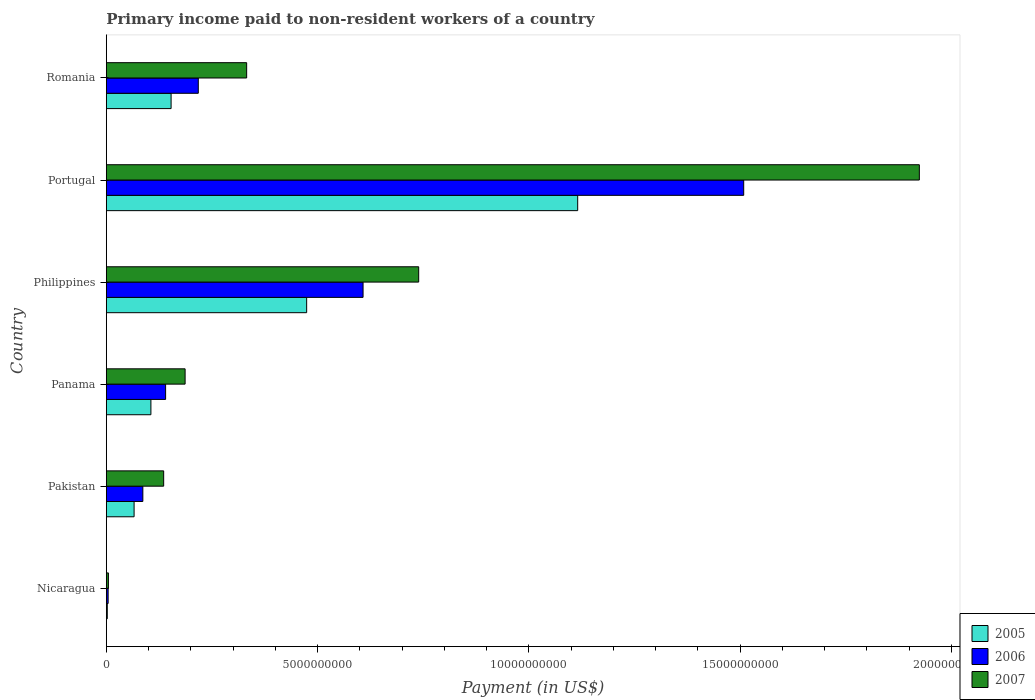Are the number of bars per tick equal to the number of legend labels?
Your response must be concise. Yes. Are the number of bars on each tick of the Y-axis equal?
Your answer should be compact. Yes. How many bars are there on the 1st tick from the top?
Make the answer very short. 3. What is the label of the 6th group of bars from the top?
Your answer should be very brief. Nicaragua. What is the amount paid to workers in 2006 in Pakistan?
Offer a terse response. 8.64e+08. Across all countries, what is the maximum amount paid to workers in 2006?
Your answer should be very brief. 1.51e+1. Across all countries, what is the minimum amount paid to workers in 2006?
Offer a terse response. 4.26e+07. In which country was the amount paid to workers in 2007 maximum?
Offer a terse response. Portugal. In which country was the amount paid to workers in 2006 minimum?
Provide a succinct answer. Nicaragua. What is the total amount paid to workers in 2007 in the graph?
Offer a very short reply. 3.32e+1. What is the difference between the amount paid to workers in 2007 in Philippines and that in Romania?
Provide a short and direct response. 4.07e+09. What is the difference between the amount paid to workers in 2007 in Nicaragua and the amount paid to workers in 2006 in Portugal?
Your answer should be compact. -1.50e+1. What is the average amount paid to workers in 2005 per country?
Ensure brevity in your answer.  3.19e+09. What is the ratio of the amount paid to workers in 2007 in Philippines to that in Romania?
Keep it short and to the point. 2.23. Is the amount paid to workers in 2005 in Pakistan less than that in Romania?
Your answer should be very brief. Yes. What is the difference between the highest and the second highest amount paid to workers in 2006?
Keep it short and to the point. 9.01e+09. What is the difference between the highest and the lowest amount paid to workers in 2005?
Offer a very short reply. 1.11e+1. In how many countries, is the amount paid to workers in 2005 greater than the average amount paid to workers in 2005 taken over all countries?
Provide a succinct answer. 2. Is the sum of the amount paid to workers in 2006 in Portugal and Romania greater than the maximum amount paid to workers in 2005 across all countries?
Provide a short and direct response. Yes. What does the 1st bar from the bottom in Portugal represents?
Make the answer very short. 2005. Is it the case that in every country, the sum of the amount paid to workers in 2006 and amount paid to workers in 2007 is greater than the amount paid to workers in 2005?
Offer a terse response. Yes. How many bars are there?
Offer a very short reply. 18. Are all the bars in the graph horizontal?
Offer a terse response. Yes. How many countries are there in the graph?
Offer a very short reply. 6. What is the difference between two consecutive major ticks on the X-axis?
Your answer should be very brief. 5.00e+09. Are the values on the major ticks of X-axis written in scientific E-notation?
Ensure brevity in your answer.  No. Does the graph contain any zero values?
Offer a very short reply. No. What is the title of the graph?
Ensure brevity in your answer.  Primary income paid to non-resident workers of a country. Does "1986" appear as one of the legend labels in the graph?
Keep it short and to the point. No. What is the label or title of the X-axis?
Your answer should be very brief. Payment (in US$). What is the label or title of the Y-axis?
Your answer should be compact. Country. What is the Payment (in US$) of 2005 in Nicaragua?
Offer a terse response. 2.27e+07. What is the Payment (in US$) in 2006 in Nicaragua?
Provide a succinct answer. 4.26e+07. What is the Payment (in US$) of 2007 in Nicaragua?
Your answer should be very brief. 4.96e+07. What is the Payment (in US$) in 2005 in Pakistan?
Provide a short and direct response. 6.57e+08. What is the Payment (in US$) in 2006 in Pakistan?
Keep it short and to the point. 8.64e+08. What is the Payment (in US$) of 2007 in Pakistan?
Ensure brevity in your answer.  1.36e+09. What is the Payment (in US$) in 2005 in Panama?
Offer a terse response. 1.05e+09. What is the Payment (in US$) in 2006 in Panama?
Provide a short and direct response. 1.40e+09. What is the Payment (in US$) of 2007 in Panama?
Your response must be concise. 1.86e+09. What is the Payment (in US$) of 2005 in Philippines?
Provide a short and direct response. 4.74e+09. What is the Payment (in US$) of 2006 in Philippines?
Provide a succinct answer. 6.08e+09. What is the Payment (in US$) in 2007 in Philippines?
Provide a succinct answer. 7.39e+09. What is the Payment (in US$) of 2005 in Portugal?
Provide a succinct answer. 1.12e+1. What is the Payment (in US$) of 2006 in Portugal?
Your answer should be very brief. 1.51e+1. What is the Payment (in US$) of 2007 in Portugal?
Your answer should be very brief. 1.92e+1. What is the Payment (in US$) in 2005 in Romania?
Offer a very short reply. 1.53e+09. What is the Payment (in US$) in 2006 in Romania?
Your answer should be very brief. 2.18e+09. What is the Payment (in US$) of 2007 in Romania?
Provide a short and direct response. 3.32e+09. Across all countries, what is the maximum Payment (in US$) in 2005?
Provide a short and direct response. 1.12e+1. Across all countries, what is the maximum Payment (in US$) of 2006?
Ensure brevity in your answer.  1.51e+1. Across all countries, what is the maximum Payment (in US$) in 2007?
Your answer should be very brief. 1.92e+1. Across all countries, what is the minimum Payment (in US$) of 2005?
Make the answer very short. 2.27e+07. Across all countries, what is the minimum Payment (in US$) in 2006?
Provide a succinct answer. 4.26e+07. Across all countries, what is the minimum Payment (in US$) in 2007?
Give a very brief answer. 4.96e+07. What is the total Payment (in US$) in 2005 in the graph?
Give a very brief answer. 1.92e+1. What is the total Payment (in US$) in 2006 in the graph?
Ensure brevity in your answer.  2.56e+1. What is the total Payment (in US$) in 2007 in the graph?
Offer a very short reply. 3.32e+1. What is the difference between the Payment (in US$) in 2005 in Nicaragua and that in Pakistan?
Give a very brief answer. -6.34e+08. What is the difference between the Payment (in US$) in 2006 in Nicaragua and that in Pakistan?
Ensure brevity in your answer.  -8.21e+08. What is the difference between the Payment (in US$) in 2007 in Nicaragua and that in Pakistan?
Your answer should be compact. -1.31e+09. What is the difference between the Payment (in US$) in 2005 in Nicaragua and that in Panama?
Provide a short and direct response. -1.03e+09. What is the difference between the Payment (in US$) of 2006 in Nicaragua and that in Panama?
Provide a short and direct response. -1.36e+09. What is the difference between the Payment (in US$) in 2007 in Nicaragua and that in Panama?
Give a very brief answer. -1.81e+09. What is the difference between the Payment (in US$) of 2005 in Nicaragua and that in Philippines?
Your response must be concise. -4.72e+09. What is the difference between the Payment (in US$) of 2006 in Nicaragua and that in Philippines?
Provide a succinct answer. -6.03e+09. What is the difference between the Payment (in US$) in 2007 in Nicaragua and that in Philippines?
Offer a terse response. -7.34e+09. What is the difference between the Payment (in US$) in 2005 in Nicaragua and that in Portugal?
Keep it short and to the point. -1.11e+1. What is the difference between the Payment (in US$) in 2006 in Nicaragua and that in Portugal?
Your answer should be compact. -1.50e+1. What is the difference between the Payment (in US$) of 2007 in Nicaragua and that in Portugal?
Your response must be concise. -1.92e+1. What is the difference between the Payment (in US$) of 2005 in Nicaragua and that in Romania?
Provide a succinct answer. -1.51e+09. What is the difference between the Payment (in US$) of 2006 in Nicaragua and that in Romania?
Provide a short and direct response. -2.13e+09. What is the difference between the Payment (in US$) of 2007 in Nicaragua and that in Romania?
Offer a terse response. -3.27e+09. What is the difference between the Payment (in US$) of 2005 in Pakistan and that in Panama?
Provide a short and direct response. -3.98e+08. What is the difference between the Payment (in US$) in 2006 in Pakistan and that in Panama?
Your response must be concise. -5.39e+08. What is the difference between the Payment (in US$) in 2007 in Pakistan and that in Panama?
Ensure brevity in your answer.  -5.07e+08. What is the difference between the Payment (in US$) of 2005 in Pakistan and that in Philippines?
Keep it short and to the point. -4.08e+09. What is the difference between the Payment (in US$) of 2006 in Pakistan and that in Philippines?
Provide a succinct answer. -5.21e+09. What is the difference between the Payment (in US$) of 2007 in Pakistan and that in Philippines?
Keep it short and to the point. -6.04e+09. What is the difference between the Payment (in US$) in 2005 in Pakistan and that in Portugal?
Provide a succinct answer. -1.05e+1. What is the difference between the Payment (in US$) in 2006 in Pakistan and that in Portugal?
Offer a very short reply. -1.42e+1. What is the difference between the Payment (in US$) in 2007 in Pakistan and that in Portugal?
Offer a very short reply. -1.79e+1. What is the difference between the Payment (in US$) in 2005 in Pakistan and that in Romania?
Your response must be concise. -8.76e+08. What is the difference between the Payment (in US$) of 2006 in Pakistan and that in Romania?
Provide a short and direct response. -1.31e+09. What is the difference between the Payment (in US$) of 2007 in Pakistan and that in Romania?
Give a very brief answer. -1.96e+09. What is the difference between the Payment (in US$) in 2005 in Panama and that in Philippines?
Your response must be concise. -3.69e+09. What is the difference between the Payment (in US$) in 2006 in Panama and that in Philippines?
Your response must be concise. -4.67e+09. What is the difference between the Payment (in US$) of 2007 in Panama and that in Philippines?
Provide a succinct answer. -5.53e+09. What is the difference between the Payment (in US$) of 2005 in Panama and that in Portugal?
Provide a succinct answer. -1.01e+1. What is the difference between the Payment (in US$) of 2006 in Panama and that in Portugal?
Provide a succinct answer. -1.37e+1. What is the difference between the Payment (in US$) in 2007 in Panama and that in Portugal?
Your response must be concise. -1.74e+1. What is the difference between the Payment (in US$) in 2005 in Panama and that in Romania?
Give a very brief answer. -4.78e+08. What is the difference between the Payment (in US$) of 2006 in Panama and that in Romania?
Your response must be concise. -7.73e+08. What is the difference between the Payment (in US$) of 2007 in Panama and that in Romania?
Give a very brief answer. -1.46e+09. What is the difference between the Payment (in US$) in 2005 in Philippines and that in Portugal?
Keep it short and to the point. -6.41e+09. What is the difference between the Payment (in US$) of 2006 in Philippines and that in Portugal?
Provide a short and direct response. -9.01e+09. What is the difference between the Payment (in US$) of 2007 in Philippines and that in Portugal?
Provide a short and direct response. -1.18e+1. What is the difference between the Payment (in US$) of 2005 in Philippines and that in Romania?
Offer a terse response. 3.21e+09. What is the difference between the Payment (in US$) of 2006 in Philippines and that in Romania?
Offer a terse response. 3.90e+09. What is the difference between the Payment (in US$) in 2007 in Philippines and that in Romania?
Ensure brevity in your answer.  4.07e+09. What is the difference between the Payment (in US$) of 2005 in Portugal and that in Romania?
Provide a succinct answer. 9.62e+09. What is the difference between the Payment (in US$) in 2006 in Portugal and that in Romania?
Ensure brevity in your answer.  1.29e+1. What is the difference between the Payment (in US$) in 2007 in Portugal and that in Romania?
Offer a terse response. 1.59e+1. What is the difference between the Payment (in US$) of 2005 in Nicaragua and the Payment (in US$) of 2006 in Pakistan?
Keep it short and to the point. -8.41e+08. What is the difference between the Payment (in US$) of 2005 in Nicaragua and the Payment (in US$) of 2007 in Pakistan?
Offer a terse response. -1.33e+09. What is the difference between the Payment (in US$) in 2006 in Nicaragua and the Payment (in US$) in 2007 in Pakistan?
Give a very brief answer. -1.31e+09. What is the difference between the Payment (in US$) of 2005 in Nicaragua and the Payment (in US$) of 2006 in Panama?
Offer a terse response. -1.38e+09. What is the difference between the Payment (in US$) of 2005 in Nicaragua and the Payment (in US$) of 2007 in Panama?
Keep it short and to the point. -1.84e+09. What is the difference between the Payment (in US$) of 2006 in Nicaragua and the Payment (in US$) of 2007 in Panama?
Make the answer very short. -1.82e+09. What is the difference between the Payment (in US$) in 2005 in Nicaragua and the Payment (in US$) in 2006 in Philippines?
Make the answer very short. -6.05e+09. What is the difference between the Payment (in US$) in 2005 in Nicaragua and the Payment (in US$) in 2007 in Philippines?
Your response must be concise. -7.37e+09. What is the difference between the Payment (in US$) in 2006 in Nicaragua and the Payment (in US$) in 2007 in Philippines?
Offer a very short reply. -7.35e+09. What is the difference between the Payment (in US$) of 2005 in Nicaragua and the Payment (in US$) of 2006 in Portugal?
Your response must be concise. -1.51e+1. What is the difference between the Payment (in US$) in 2005 in Nicaragua and the Payment (in US$) in 2007 in Portugal?
Ensure brevity in your answer.  -1.92e+1. What is the difference between the Payment (in US$) of 2006 in Nicaragua and the Payment (in US$) of 2007 in Portugal?
Keep it short and to the point. -1.92e+1. What is the difference between the Payment (in US$) of 2005 in Nicaragua and the Payment (in US$) of 2006 in Romania?
Provide a succinct answer. -2.15e+09. What is the difference between the Payment (in US$) of 2005 in Nicaragua and the Payment (in US$) of 2007 in Romania?
Make the answer very short. -3.30e+09. What is the difference between the Payment (in US$) of 2006 in Nicaragua and the Payment (in US$) of 2007 in Romania?
Provide a succinct answer. -3.28e+09. What is the difference between the Payment (in US$) of 2005 in Pakistan and the Payment (in US$) of 2006 in Panama?
Offer a very short reply. -7.46e+08. What is the difference between the Payment (in US$) in 2005 in Pakistan and the Payment (in US$) in 2007 in Panama?
Your response must be concise. -1.21e+09. What is the difference between the Payment (in US$) in 2006 in Pakistan and the Payment (in US$) in 2007 in Panama?
Keep it short and to the point. -1.00e+09. What is the difference between the Payment (in US$) in 2005 in Pakistan and the Payment (in US$) in 2006 in Philippines?
Your answer should be compact. -5.42e+09. What is the difference between the Payment (in US$) of 2005 in Pakistan and the Payment (in US$) of 2007 in Philippines?
Give a very brief answer. -6.74e+09. What is the difference between the Payment (in US$) of 2006 in Pakistan and the Payment (in US$) of 2007 in Philippines?
Your response must be concise. -6.53e+09. What is the difference between the Payment (in US$) in 2005 in Pakistan and the Payment (in US$) in 2006 in Portugal?
Give a very brief answer. -1.44e+1. What is the difference between the Payment (in US$) of 2005 in Pakistan and the Payment (in US$) of 2007 in Portugal?
Offer a very short reply. -1.86e+1. What is the difference between the Payment (in US$) in 2006 in Pakistan and the Payment (in US$) in 2007 in Portugal?
Keep it short and to the point. -1.84e+1. What is the difference between the Payment (in US$) in 2005 in Pakistan and the Payment (in US$) in 2006 in Romania?
Your response must be concise. -1.52e+09. What is the difference between the Payment (in US$) of 2005 in Pakistan and the Payment (in US$) of 2007 in Romania?
Give a very brief answer. -2.66e+09. What is the difference between the Payment (in US$) of 2006 in Pakistan and the Payment (in US$) of 2007 in Romania?
Your answer should be very brief. -2.46e+09. What is the difference between the Payment (in US$) of 2005 in Panama and the Payment (in US$) of 2006 in Philippines?
Your response must be concise. -5.02e+09. What is the difference between the Payment (in US$) of 2005 in Panama and the Payment (in US$) of 2007 in Philippines?
Keep it short and to the point. -6.34e+09. What is the difference between the Payment (in US$) of 2006 in Panama and the Payment (in US$) of 2007 in Philippines?
Offer a terse response. -5.99e+09. What is the difference between the Payment (in US$) of 2005 in Panama and the Payment (in US$) of 2006 in Portugal?
Your answer should be very brief. -1.40e+1. What is the difference between the Payment (in US$) of 2005 in Panama and the Payment (in US$) of 2007 in Portugal?
Ensure brevity in your answer.  -1.82e+1. What is the difference between the Payment (in US$) in 2006 in Panama and the Payment (in US$) in 2007 in Portugal?
Keep it short and to the point. -1.78e+1. What is the difference between the Payment (in US$) of 2005 in Panama and the Payment (in US$) of 2006 in Romania?
Keep it short and to the point. -1.12e+09. What is the difference between the Payment (in US$) in 2005 in Panama and the Payment (in US$) in 2007 in Romania?
Provide a short and direct response. -2.27e+09. What is the difference between the Payment (in US$) of 2006 in Panama and the Payment (in US$) of 2007 in Romania?
Offer a terse response. -1.92e+09. What is the difference between the Payment (in US$) of 2005 in Philippines and the Payment (in US$) of 2006 in Portugal?
Your answer should be compact. -1.03e+1. What is the difference between the Payment (in US$) of 2005 in Philippines and the Payment (in US$) of 2007 in Portugal?
Provide a short and direct response. -1.45e+1. What is the difference between the Payment (in US$) of 2006 in Philippines and the Payment (in US$) of 2007 in Portugal?
Your response must be concise. -1.32e+1. What is the difference between the Payment (in US$) in 2005 in Philippines and the Payment (in US$) in 2006 in Romania?
Make the answer very short. 2.56e+09. What is the difference between the Payment (in US$) in 2005 in Philippines and the Payment (in US$) in 2007 in Romania?
Provide a succinct answer. 1.42e+09. What is the difference between the Payment (in US$) of 2006 in Philippines and the Payment (in US$) of 2007 in Romania?
Offer a terse response. 2.75e+09. What is the difference between the Payment (in US$) of 2005 in Portugal and the Payment (in US$) of 2006 in Romania?
Ensure brevity in your answer.  8.98e+09. What is the difference between the Payment (in US$) of 2005 in Portugal and the Payment (in US$) of 2007 in Romania?
Your answer should be compact. 7.83e+09. What is the difference between the Payment (in US$) in 2006 in Portugal and the Payment (in US$) in 2007 in Romania?
Make the answer very short. 1.18e+1. What is the average Payment (in US$) of 2005 per country?
Ensure brevity in your answer.  3.19e+09. What is the average Payment (in US$) of 2006 per country?
Keep it short and to the point. 4.27e+09. What is the average Payment (in US$) of 2007 per country?
Provide a succinct answer. 5.54e+09. What is the difference between the Payment (in US$) of 2005 and Payment (in US$) of 2006 in Nicaragua?
Provide a succinct answer. -1.99e+07. What is the difference between the Payment (in US$) in 2005 and Payment (in US$) in 2007 in Nicaragua?
Offer a very short reply. -2.69e+07. What is the difference between the Payment (in US$) in 2006 and Payment (in US$) in 2007 in Nicaragua?
Make the answer very short. -7.00e+06. What is the difference between the Payment (in US$) in 2005 and Payment (in US$) in 2006 in Pakistan?
Provide a succinct answer. -2.07e+08. What is the difference between the Payment (in US$) in 2005 and Payment (in US$) in 2007 in Pakistan?
Your answer should be very brief. -7.00e+08. What is the difference between the Payment (in US$) of 2006 and Payment (in US$) of 2007 in Pakistan?
Your response must be concise. -4.93e+08. What is the difference between the Payment (in US$) in 2005 and Payment (in US$) in 2006 in Panama?
Provide a succinct answer. -3.48e+08. What is the difference between the Payment (in US$) of 2005 and Payment (in US$) of 2007 in Panama?
Make the answer very short. -8.09e+08. What is the difference between the Payment (in US$) of 2006 and Payment (in US$) of 2007 in Panama?
Your answer should be compact. -4.61e+08. What is the difference between the Payment (in US$) in 2005 and Payment (in US$) in 2006 in Philippines?
Your answer should be very brief. -1.33e+09. What is the difference between the Payment (in US$) of 2005 and Payment (in US$) of 2007 in Philippines?
Offer a very short reply. -2.65e+09. What is the difference between the Payment (in US$) in 2006 and Payment (in US$) in 2007 in Philippines?
Keep it short and to the point. -1.32e+09. What is the difference between the Payment (in US$) in 2005 and Payment (in US$) in 2006 in Portugal?
Your answer should be compact. -3.93e+09. What is the difference between the Payment (in US$) in 2005 and Payment (in US$) in 2007 in Portugal?
Ensure brevity in your answer.  -8.09e+09. What is the difference between the Payment (in US$) of 2006 and Payment (in US$) of 2007 in Portugal?
Provide a succinct answer. -4.16e+09. What is the difference between the Payment (in US$) of 2005 and Payment (in US$) of 2006 in Romania?
Provide a short and direct response. -6.44e+08. What is the difference between the Payment (in US$) of 2005 and Payment (in US$) of 2007 in Romania?
Keep it short and to the point. -1.79e+09. What is the difference between the Payment (in US$) in 2006 and Payment (in US$) in 2007 in Romania?
Provide a succinct answer. -1.14e+09. What is the ratio of the Payment (in US$) of 2005 in Nicaragua to that in Pakistan?
Keep it short and to the point. 0.03. What is the ratio of the Payment (in US$) of 2006 in Nicaragua to that in Pakistan?
Provide a short and direct response. 0.05. What is the ratio of the Payment (in US$) of 2007 in Nicaragua to that in Pakistan?
Keep it short and to the point. 0.04. What is the ratio of the Payment (in US$) in 2005 in Nicaragua to that in Panama?
Give a very brief answer. 0.02. What is the ratio of the Payment (in US$) in 2006 in Nicaragua to that in Panama?
Your answer should be very brief. 0.03. What is the ratio of the Payment (in US$) of 2007 in Nicaragua to that in Panama?
Your answer should be compact. 0.03. What is the ratio of the Payment (in US$) of 2005 in Nicaragua to that in Philippines?
Give a very brief answer. 0. What is the ratio of the Payment (in US$) of 2006 in Nicaragua to that in Philippines?
Ensure brevity in your answer.  0.01. What is the ratio of the Payment (in US$) of 2007 in Nicaragua to that in Philippines?
Keep it short and to the point. 0.01. What is the ratio of the Payment (in US$) of 2005 in Nicaragua to that in Portugal?
Make the answer very short. 0. What is the ratio of the Payment (in US$) in 2006 in Nicaragua to that in Portugal?
Provide a succinct answer. 0. What is the ratio of the Payment (in US$) in 2007 in Nicaragua to that in Portugal?
Offer a very short reply. 0. What is the ratio of the Payment (in US$) in 2005 in Nicaragua to that in Romania?
Provide a short and direct response. 0.01. What is the ratio of the Payment (in US$) of 2006 in Nicaragua to that in Romania?
Your answer should be compact. 0.02. What is the ratio of the Payment (in US$) in 2007 in Nicaragua to that in Romania?
Keep it short and to the point. 0.01. What is the ratio of the Payment (in US$) in 2005 in Pakistan to that in Panama?
Offer a very short reply. 0.62. What is the ratio of the Payment (in US$) of 2006 in Pakistan to that in Panama?
Provide a short and direct response. 0.62. What is the ratio of the Payment (in US$) in 2007 in Pakistan to that in Panama?
Your answer should be very brief. 0.73. What is the ratio of the Payment (in US$) in 2005 in Pakistan to that in Philippines?
Offer a terse response. 0.14. What is the ratio of the Payment (in US$) of 2006 in Pakistan to that in Philippines?
Provide a succinct answer. 0.14. What is the ratio of the Payment (in US$) in 2007 in Pakistan to that in Philippines?
Offer a terse response. 0.18. What is the ratio of the Payment (in US$) of 2005 in Pakistan to that in Portugal?
Give a very brief answer. 0.06. What is the ratio of the Payment (in US$) in 2006 in Pakistan to that in Portugal?
Make the answer very short. 0.06. What is the ratio of the Payment (in US$) in 2007 in Pakistan to that in Portugal?
Make the answer very short. 0.07. What is the ratio of the Payment (in US$) in 2005 in Pakistan to that in Romania?
Your answer should be very brief. 0.43. What is the ratio of the Payment (in US$) in 2006 in Pakistan to that in Romania?
Provide a short and direct response. 0.4. What is the ratio of the Payment (in US$) in 2007 in Pakistan to that in Romania?
Ensure brevity in your answer.  0.41. What is the ratio of the Payment (in US$) of 2005 in Panama to that in Philippines?
Your answer should be very brief. 0.22. What is the ratio of the Payment (in US$) of 2006 in Panama to that in Philippines?
Ensure brevity in your answer.  0.23. What is the ratio of the Payment (in US$) in 2007 in Panama to that in Philippines?
Your answer should be compact. 0.25. What is the ratio of the Payment (in US$) of 2005 in Panama to that in Portugal?
Offer a terse response. 0.09. What is the ratio of the Payment (in US$) of 2006 in Panama to that in Portugal?
Make the answer very short. 0.09. What is the ratio of the Payment (in US$) in 2007 in Panama to that in Portugal?
Offer a very short reply. 0.1. What is the ratio of the Payment (in US$) in 2005 in Panama to that in Romania?
Your answer should be very brief. 0.69. What is the ratio of the Payment (in US$) in 2006 in Panama to that in Romania?
Offer a very short reply. 0.64. What is the ratio of the Payment (in US$) of 2007 in Panama to that in Romania?
Keep it short and to the point. 0.56. What is the ratio of the Payment (in US$) of 2005 in Philippines to that in Portugal?
Provide a succinct answer. 0.42. What is the ratio of the Payment (in US$) in 2006 in Philippines to that in Portugal?
Offer a very short reply. 0.4. What is the ratio of the Payment (in US$) in 2007 in Philippines to that in Portugal?
Your answer should be compact. 0.38. What is the ratio of the Payment (in US$) of 2005 in Philippines to that in Romania?
Offer a terse response. 3.09. What is the ratio of the Payment (in US$) in 2006 in Philippines to that in Romania?
Offer a very short reply. 2.79. What is the ratio of the Payment (in US$) of 2007 in Philippines to that in Romania?
Your answer should be very brief. 2.23. What is the ratio of the Payment (in US$) of 2005 in Portugal to that in Romania?
Give a very brief answer. 7.28. What is the ratio of the Payment (in US$) in 2006 in Portugal to that in Romania?
Your answer should be very brief. 6.93. What is the ratio of the Payment (in US$) of 2007 in Portugal to that in Romania?
Make the answer very short. 5.79. What is the difference between the highest and the second highest Payment (in US$) of 2005?
Keep it short and to the point. 6.41e+09. What is the difference between the highest and the second highest Payment (in US$) in 2006?
Your answer should be very brief. 9.01e+09. What is the difference between the highest and the second highest Payment (in US$) of 2007?
Offer a very short reply. 1.18e+1. What is the difference between the highest and the lowest Payment (in US$) of 2005?
Offer a terse response. 1.11e+1. What is the difference between the highest and the lowest Payment (in US$) in 2006?
Your answer should be compact. 1.50e+1. What is the difference between the highest and the lowest Payment (in US$) of 2007?
Make the answer very short. 1.92e+1. 